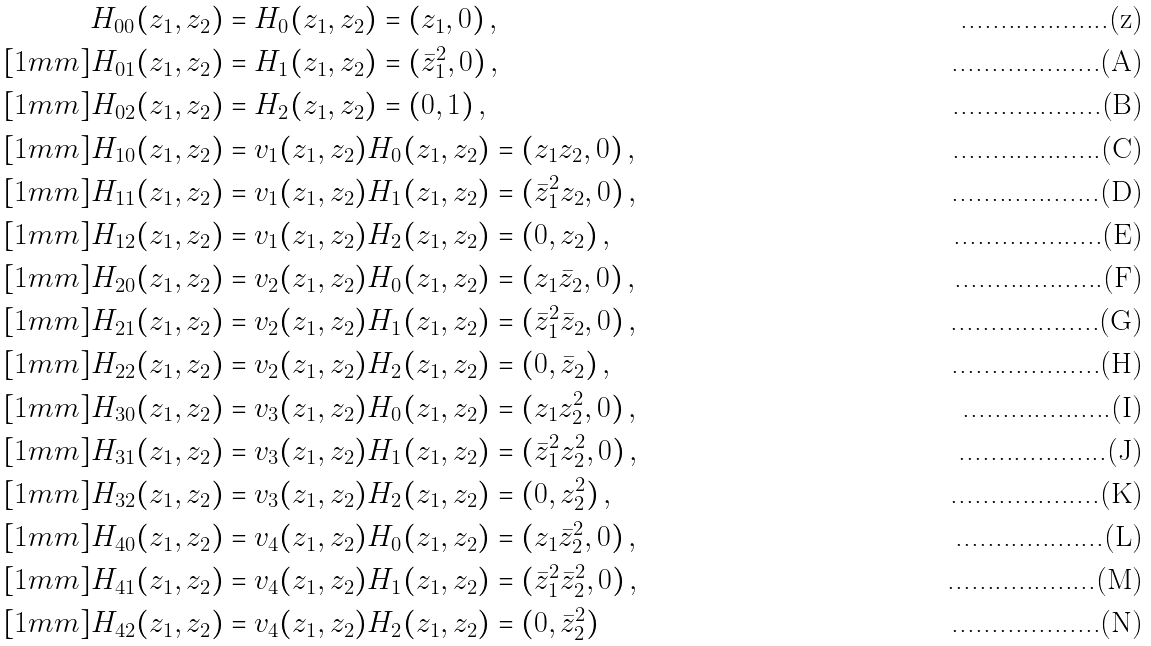<formula> <loc_0><loc_0><loc_500><loc_500>H _ { 0 0 } ( z _ { 1 } , z _ { 2 } ) & = H _ { 0 } ( z _ { 1 } , z _ { 2 } ) = ( z _ { 1 } , 0 ) \, , \\ [ 1 m m ] H _ { 0 1 } ( z _ { 1 } , z _ { 2 } ) & = H _ { 1 } ( z _ { 1 } , z _ { 2 } ) = ( \bar { z } _ { 1 } ^ { 2 } , 0 ) \, , \\ [ 1 m m ] H _ { 0 2 } ( z _ { 1 } , z _ { 2 } ) & = H _ { 2 } ( z _ { 1 } , z _ { 2 } ) = ( 0 , 1 ) \, , \\ [ 1 m m ] H _ { 1 0 } ( z _ { 1 } , z _ { 2 } ) & = v _ { 1 } ( z _ { 1 } , z _ { 2 } ) H _ { 0 } ( z _ { 1 } , z _ { 2 } ) = ( z _ { 1 } z _ { 2 } , 0 ) \, , \\ [ 1 m m ] H _ { 1 1 } ( z _ { 1 } , z _ { 2 } ) & = v _ { 1 } ( z _ { 1 } , z _ { 2 } ) H _ { 1 } ( z _ { 1 } , z _ { 2 } ) = ( \bar { z } _ { 1 } ^ { 2 } z _ { 2 } , 0 ) \, , \\ [ 1 m m ] H _ { 1 2 } ( z _ { 1 } , z _ { 2 } ) & = v _ { 1 } ( z _ { 1 } , z _ { 2 } ) H _ { 2 } ( z _ { 1 } , z _ { 2 } ) = ( 0 , z _ { 2 } ) \, , \\ [ 1 m m ] H _ { 2 0 } ( z _ { 1 } , z _ { 2 } ) & = v _ { 2 } ( z _ { 1 } , z _ { 2 } ) H _ { 0 } ( z _ { 1 } , z _ { 2 } ) = ( z _ { 1 } \bar { z } _ { 2 } , 0 ) \, , \\ [ 1 m m ] H _ { 2 1 } ( z _ { 1 } , z _ { 2 } ) & = v _ { 2 } ( z _ { 1 } , z _ { 2 } ) H _ { 1 } ( z _ { 1 } , z _ { 2 } ) = ( \bar { z } _ { 1 } ^ { 2 } \bar { z } _ { 2 } , 0 ) \, , \\ [ 1 m m ] H _ { 2 2 } ( z _ { 1 } , z _ { 2 } ) & = v _ { 2 } ( z _ { 1 } , z _ { 2 } ) H _ { 2 } ( z _ { 1 } , z _ { 2 } ) = ( 0 , \bar { z } _ { 2 } ) \, , \\ [ 1 m m ] H _ { 3 0 } ( z _ { 1 } , z _ { 2 } ) & = v _ { 3 } ( z _ { 1 } , z _ { 2 } ) H _ { 0 } ( z _ { 1 } , z _ { 2 } ) = ( z _ { 1 } z _ { 2 } ^ { 2 } , 0 ) \, , \\ [ 1 m m ] H _ { 3 1 } ( z _ { 1 } , z _ { 2 } ) & = v _ { 3 } ( z _ { 1 } , z _ { 2 } ) H _ { 1 } ( z _ { 1 } , z _ { 2 } ) = ( \bar { z } _ { 1 } ^ { 2 } z _ { 2 } ^ { 2 } , 0 ) \, , \\ [ 1 m m ] H _ { 3 2 } ( z _ { 1 } , z _ { 2 } ) & = v _ { 3 } ( z _ { 1 } , z _ { 2 } ) H _ { 2 } ( z _ { 1 } , z _ { 2 } ) = ( 0 , z _ { 2 } ^ { 2 } ) \, , \\ [ 1 m m ] H _ { 4 0 } ( z _ { 1 } , z _ { 2 } ) & = v _ { 4 } ( z _ { 1 } , z _ { 2 } ) H _ { 0 } ( z _ { 1 } , z _ { 2 } ) = ( z _ { 1 } \bar { z } _ { 2 } ^ { 2 } , 0 ) \, , \\ [ 1 m m ] H _ { 4 1 } ( z _ { 1 } , z _ { 2 } ) & = v _ { 4 } ( z _ { 1 } , z _ { 2 } ) H _ { 1 } ( z _ { 1 } , z _ { 2 } ) = ( \bar { z } _ { 1 } ^ { 2 } \bar { z } _ { 2 } ^ { 2 } , 0 ) \, , \\ [ 1 m m ] H _ { 4 2 } ( z _ { 1 } , z _ { 2 } ) & = v _ { 4 } ( z _ { 1 } , z _ { 2 } ) H _ { 2 } ( z _ { 1 } , z _ { 2 } ) = ( 0 , \bar { z } _ { 2 } ^ { 2 } )</formula> 